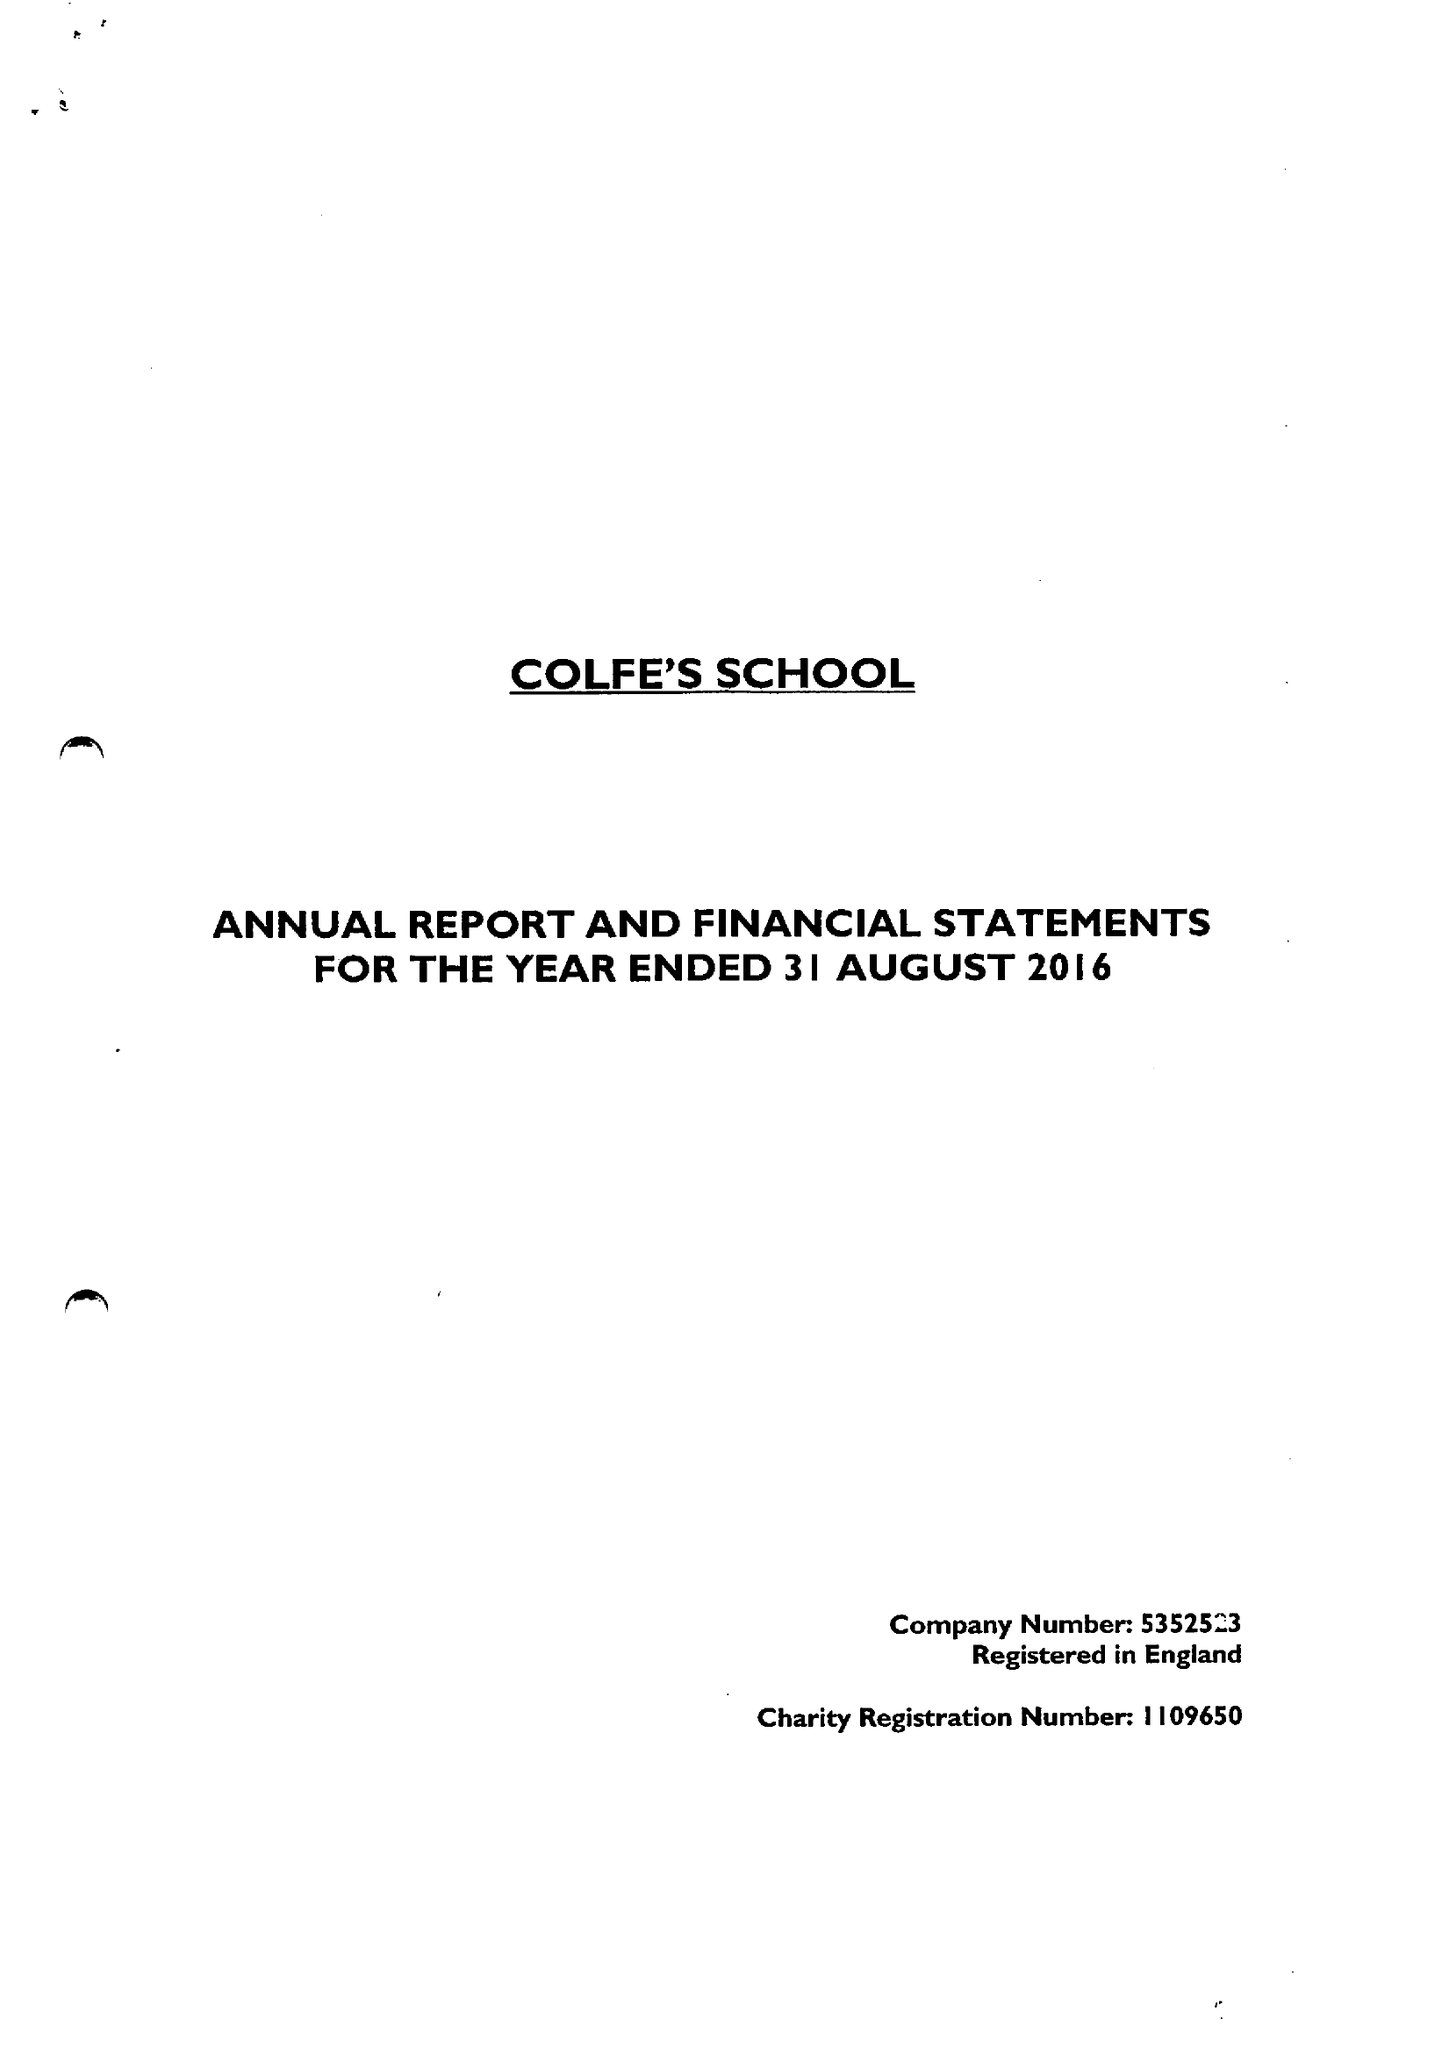What is the value for the address__street_line?
Answer the question using a single word or phrase. HORN PARK LANE 